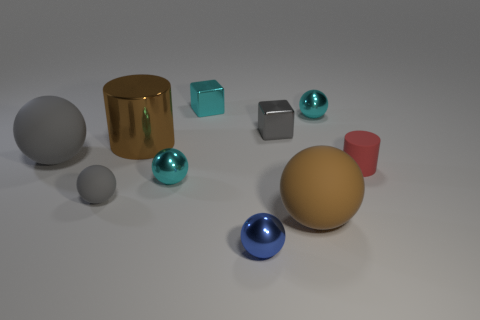Are there any other things that are the same color as the rubber cylinder? Yes, the red rubber cylinder matches the color of the red sphere in the foreground of the image. Both share a vibrant, red hue which distinguishes them from the other objects in the scene. 